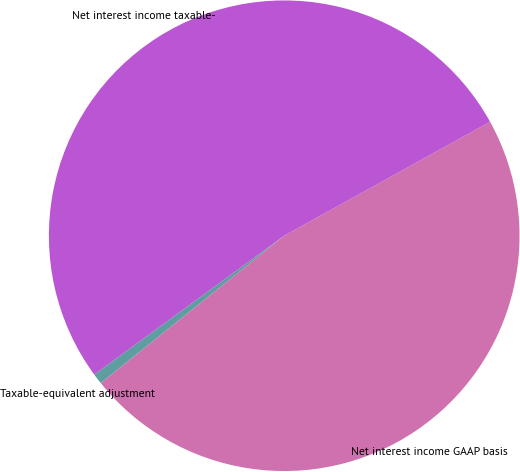Convert chart. <chart><loc_0><loc_0><loc_500><loc_500><pie_chart><fcel>Net interest income GAAP basis<fcel>Taxable-equivalent adjustment<fcel>Net interest income taxable-<nl><fcel>47.27%<fcel>0.72%<fcel>52.0%<nl></chart> 